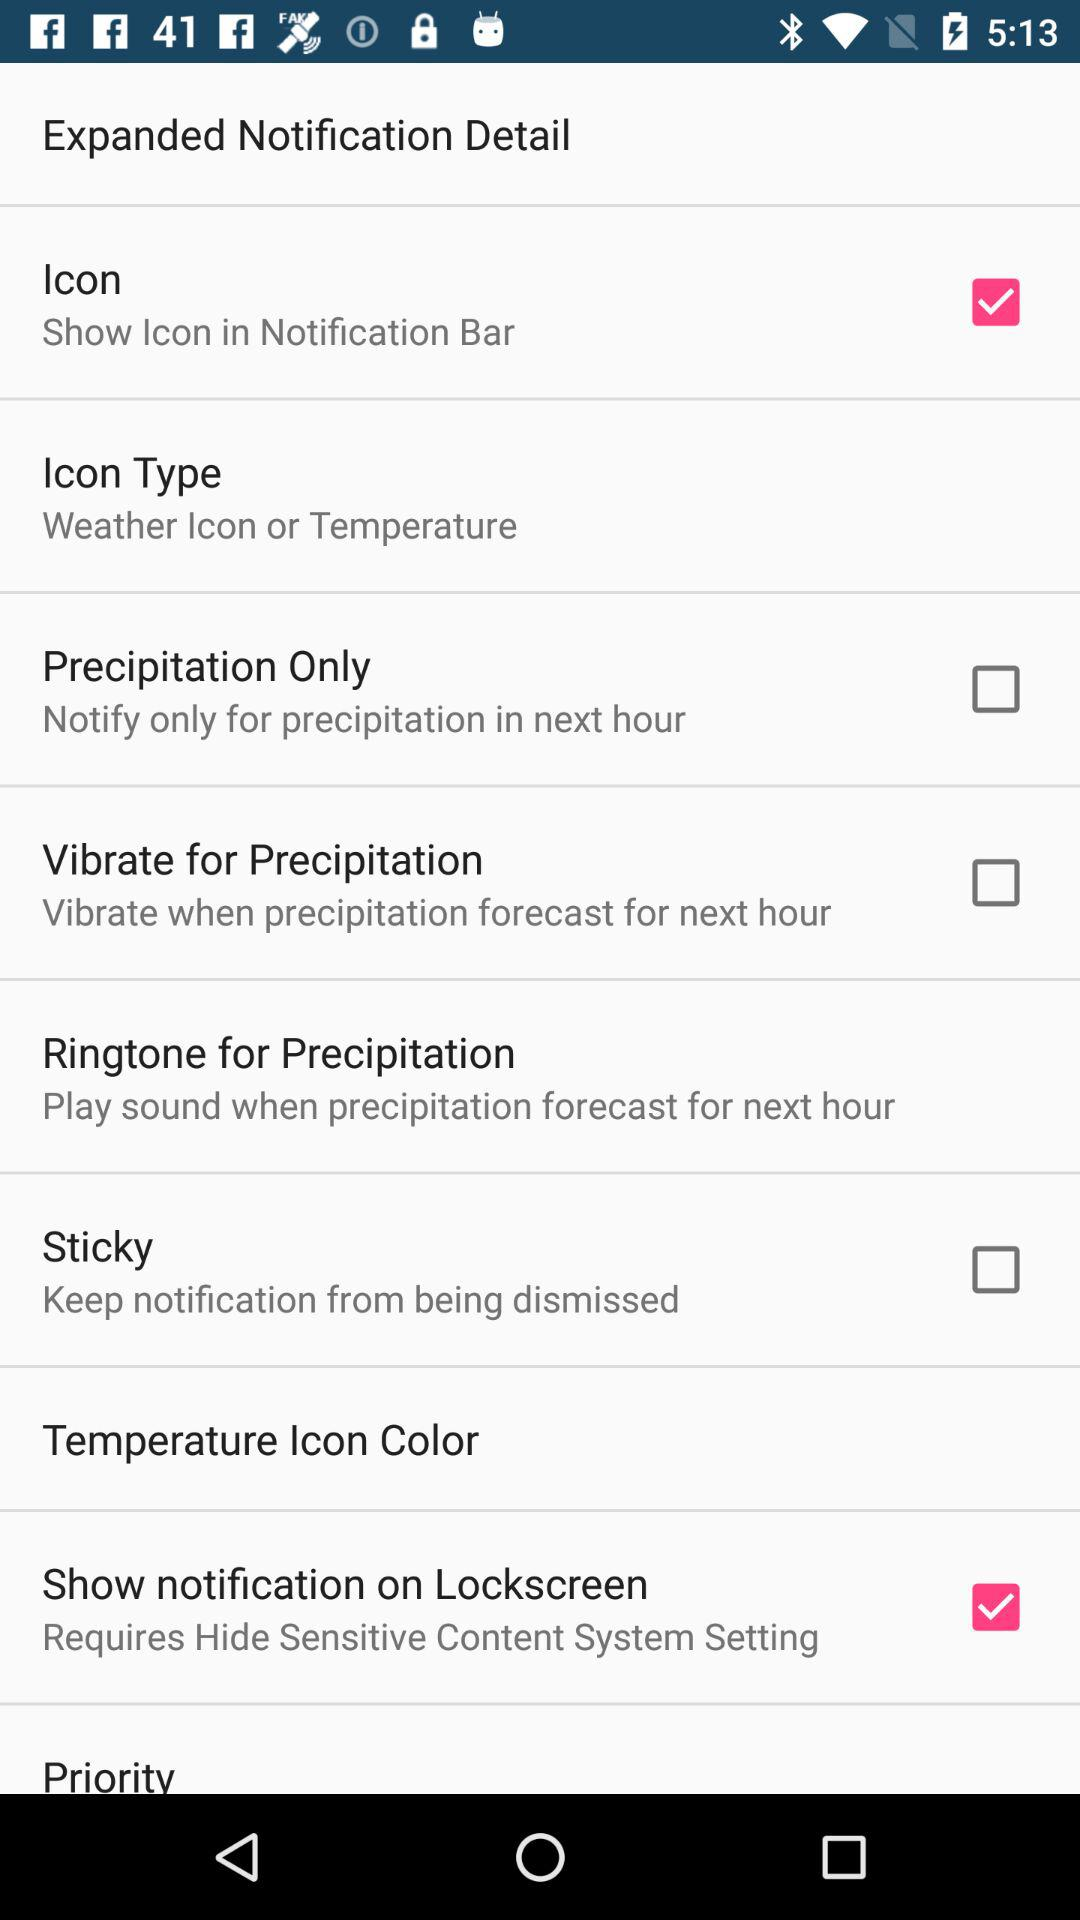What options are given in the "Icon Type" setting? The given option is "Weather Icon or Temperature". 